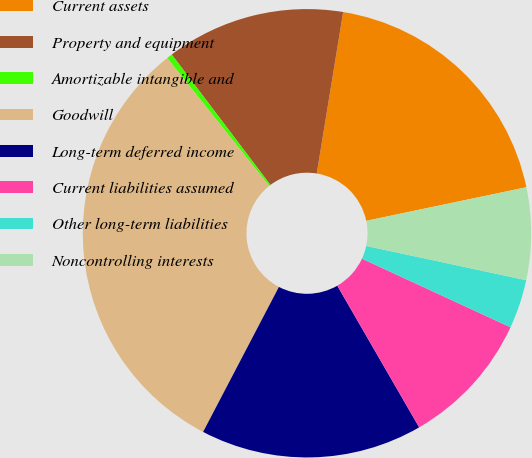Convert chart. <chart><loc_0><loc_0><loc_500><loc_500><pie_chart><fcel>Current assets<fcel>Property and equipment<fcel>Amortizable intangible and<fcel>Goodwill<fcel>Long-term deferred income<fcel>Current liabilities assumed<fcel>Other long-term liabilities<fcel>Noncontrolling interests<nl><fcel>19.13%<fcel>12.89%<fcel>0.41%<fcel>31.61%<fcel>16.01%<fcel>9.77%<fcel>3.53%<fcel>6.65%<nl></chart> 